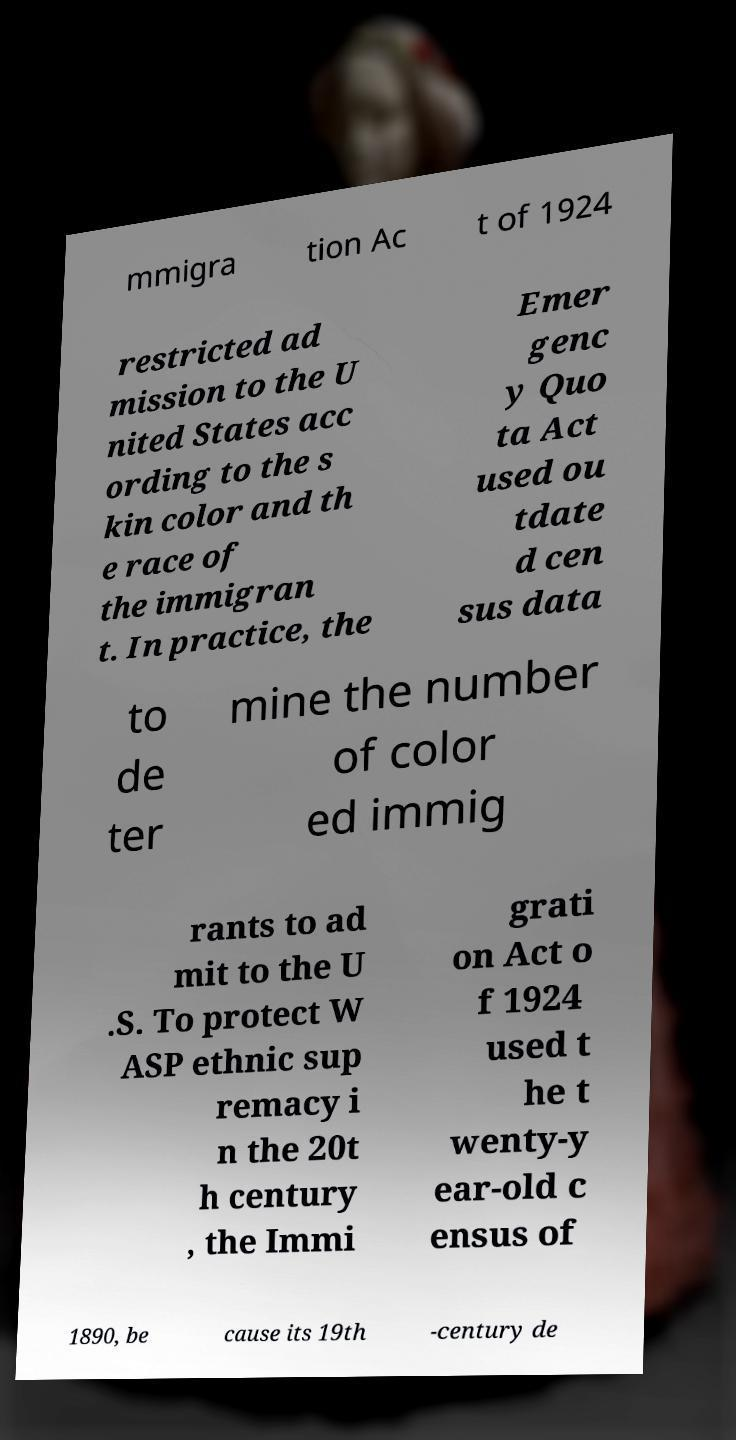For documentation purposes, I need the text within this image transcribed. Could you provide that? mmigra tion Ac t of 1924 restricted ad mission to the U nited States acc ording to the s kin color and th e race of the immigran t. In practice, the Emer genc y Quo ta Act used ou tdate d cen sus data to de ter mine the number of color ed immig rants to ad mit to the U .S. To protect W ASP ethnic sup remacy i n the 20t h century , the Immi grati on Act o f 1924 used t he t wenty-y ear-old c ensus of 1890, be cause its 19th -century de 